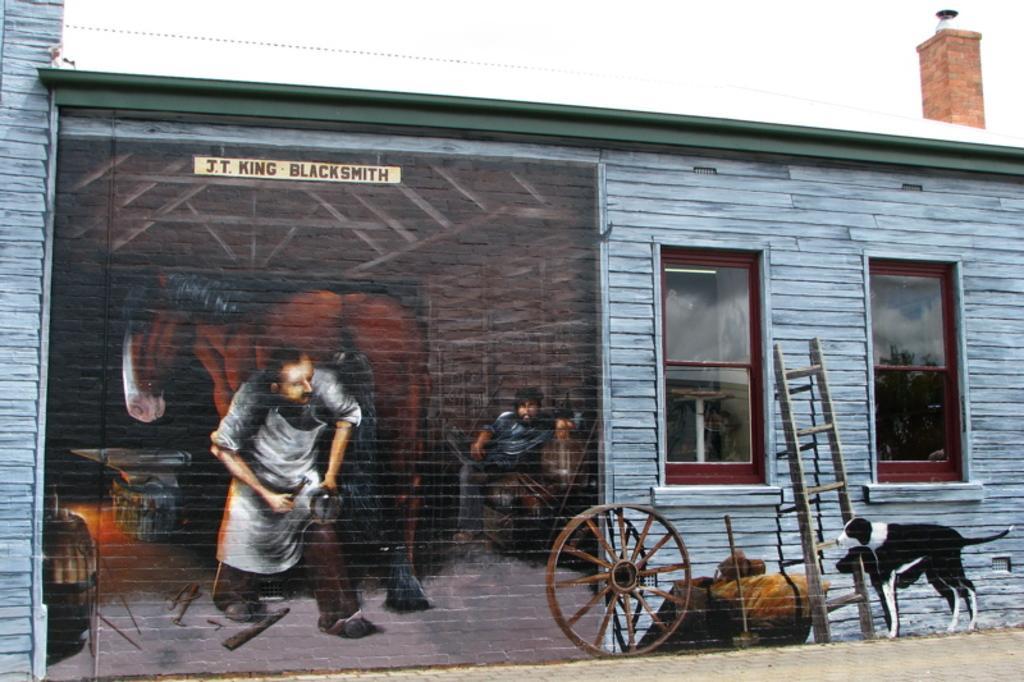How would you summarize this image in a sentence or two? Here I can see a wall along with the windows. There is a poster attached to this wall. On this poster I can see two persons and some text. At the bottom of the image I can see the road. On the right side there is a dog, ladder, few rocks and a wheel. At the top I can see the sky. 